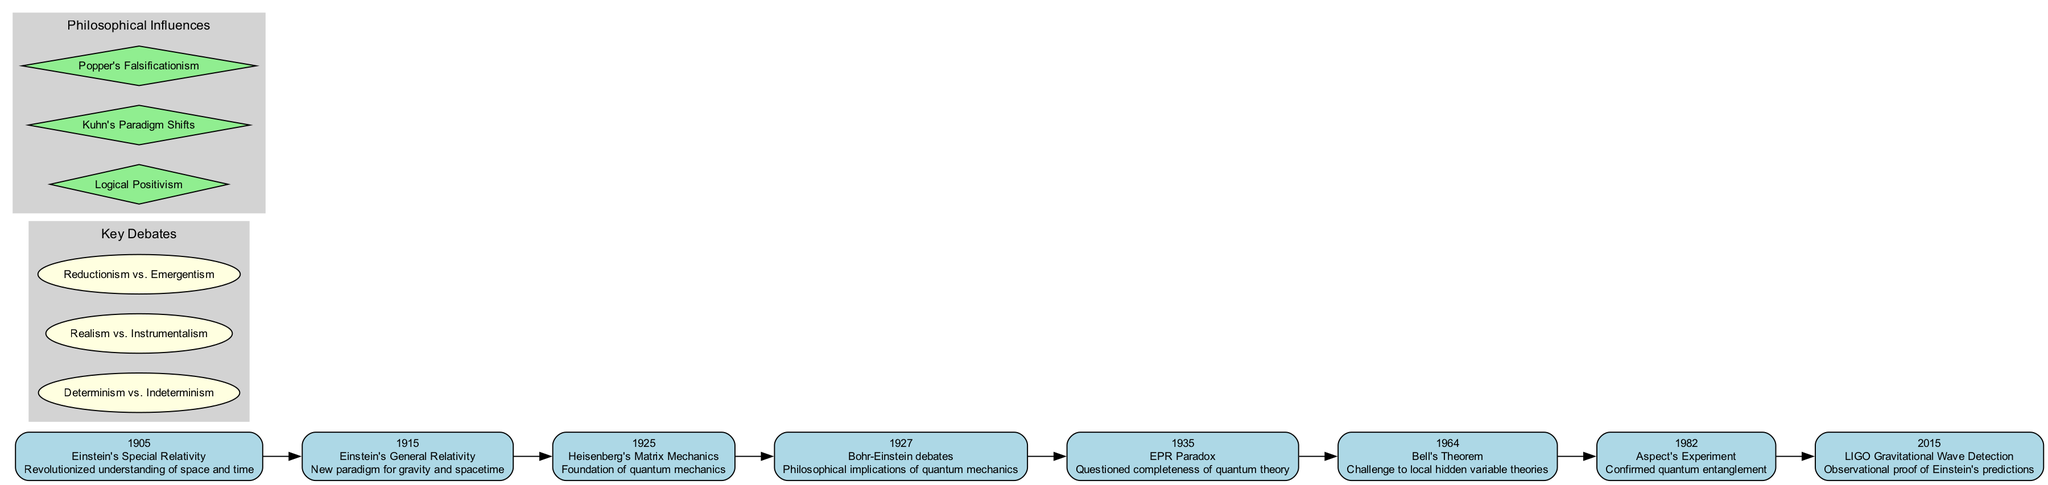What year did Einstein introduce General Relativity? By locating the event labeled "Einstein's General Relativity" on the timeline, we see that it is associated with the year 1915.
Answer: 1915 How many key debates are presented in the diagram? The diagram lists three key debates in a designated section, as indicated by the number of ellipse-shaped nodes grouped within the "Key Debates" cluster.
Answer: 3 What impact did Bell's Theorem have on scientific theories? Referring to the event labeled "Bell's Theorem," the impact description states it was a "Challenge to local hidden variable theories," indicating a significant change in perspective regarding quantum mechanics.
Answer: Challenge to local hidden variable theories Which event followed Aspect's Experiment on the timeline? By reviewing the ordered events, we note that "LIGO Gravitational Wave Detection" took place in 2015 and is the subsequent event following "Aspect's Experiment," which occurred in 1982.
Answer: LIGO Gravitational Wave Detection What philosophical influence is associated with paradigm shifts in the diagram? The diagram highlights "Kuhn's Paradigm Shifts" among other philosophical influences, indicating its relevance to the discussions of paradigm shifts in the scientific realm.
Answer: Kuhn's Paradigm Shifts How does the event of the Bohr-Einstein debates relate to the EPR Paradox? Both are events on the timeline pertaining to the philosophical discussions around quantum mechanics, and they are sequentially connected: the Bohr-Einstein debates occurred in 1927, and the EPR Paradox followed in 1935, indicating an evolving discussion.
Answer: EPR Paradox What is the impact of Einstein's Special Relativity on scientific understanding? The impact statement for "Einstein's Special Relativity" shows that it "Revolutionized understanding of space and time," indicating a significant shift in how these concepts were perceived scientifically.
Answer: Revolutionized understanding of space and time How many events are listed on the timeline? A count of the events in the timeline will show that there are eight distinct entries concerning key advancements and debates, confirming the total number of nodes related to events.
Answer: 8 What connection exists between the 1925 event and the subsequent debates? The event "Heisenberg's Matrix Mechanics" in 1925 established the foundation of quantum mechanics, leading to intensified discussions and debates, starting with the Bohr-Einstein debates in 1927. This indicates a direct influence of experimental advancements on philosophical discussions.
Answer: Bohr-Einstein debates 